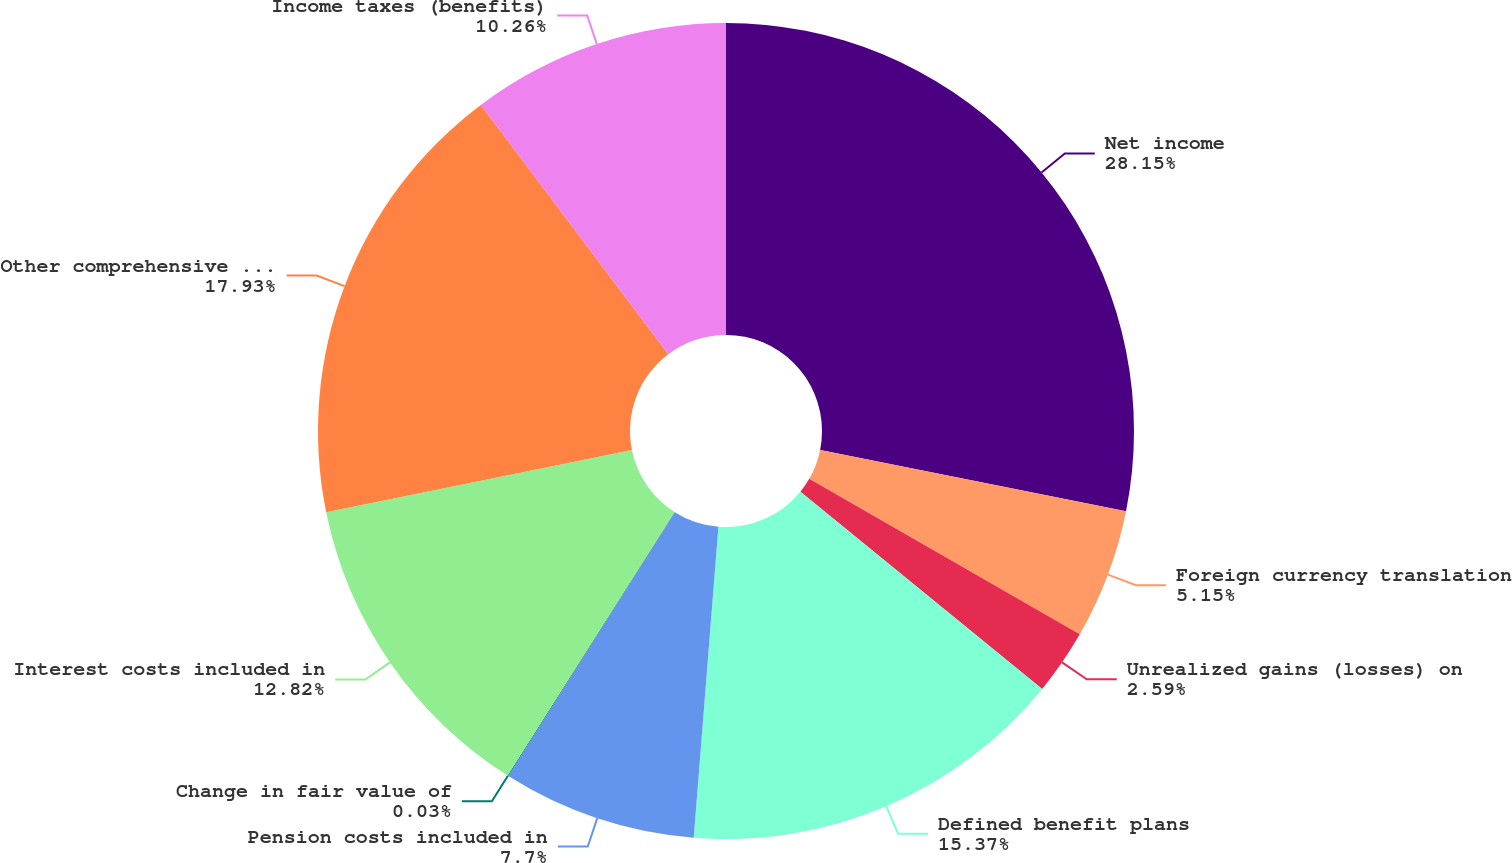<chart> <loc_0><loc_0><loc_500><loc_500><pie_chart><fcel>Net income<fcel>Foreign currency translation<fcel>Unrealized gains (losses) on<fcel>Defined benefit plans<fcel>Pension costs included in<fcel>Change in fair value of<fcel>Interest costs included in<fcel>Other comprehensive income<fcel>Income taxes (benefits)<nl><fcel>28.15%<fcel>5.15%<fcel>2.59%<fcel>15.37%<fcel>7.7%<fcel>0.03%<fcel>12.82%<fcel>17.93%<fcel>10.26%<nl></chart> 